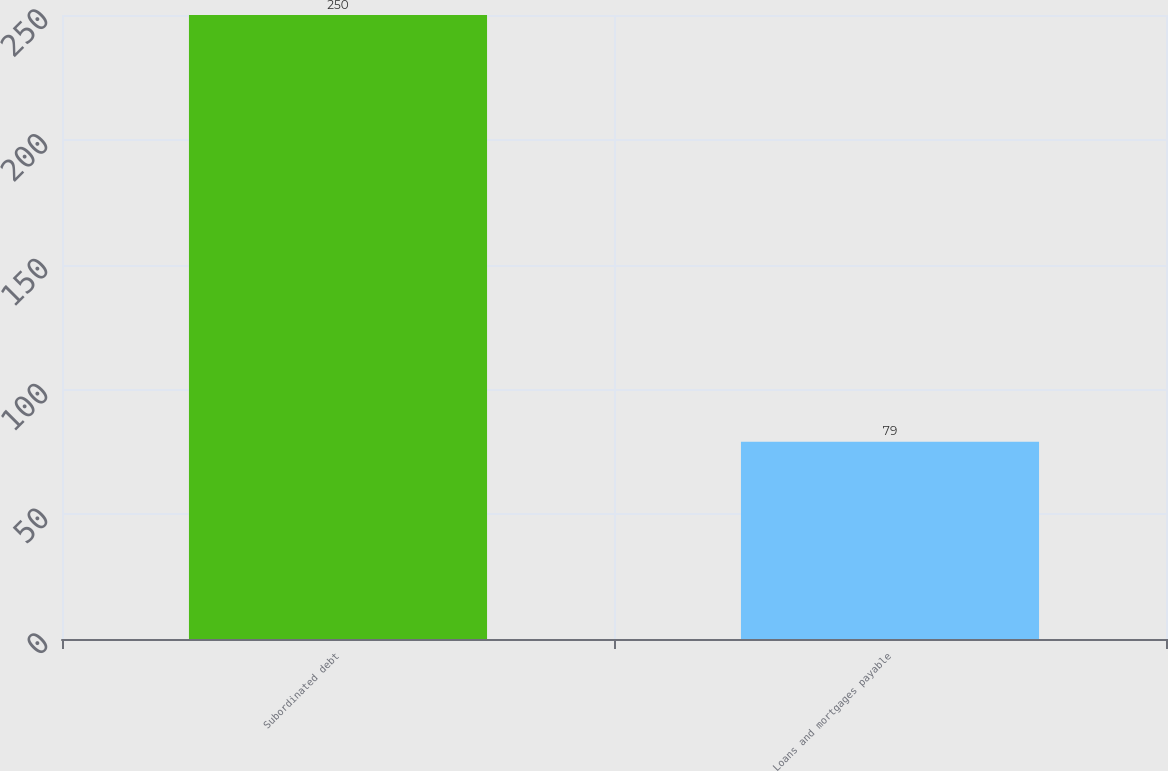Convert chart. <chart><loc_0><loc_0><loc_500><loc_500><bar_chart><fcel>Subordinated debt<fcel>Loans and mortgages payable<nl><fcel>250<fcel>79<nl></chart> 